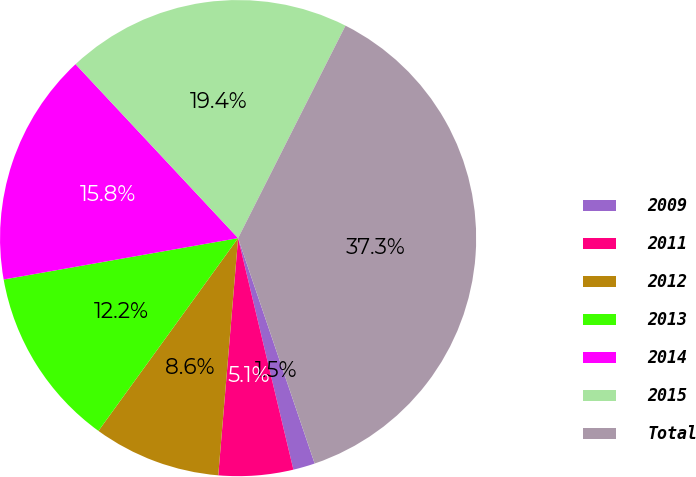<chart> <loc_0><loc_0><loc_500><loc_500><pie_chart><fcel>2009<fcel>2011<fcel>2012<fcel>2013<fcel>2014<fcel>2015<fcel>Total<nl><fcel>1.48%<fcel>5.06%<fcel>8.65%<fcel>12.24%<fcel>15.82%<fcel>19.41%<fcel>37.34%<nl></chart> 